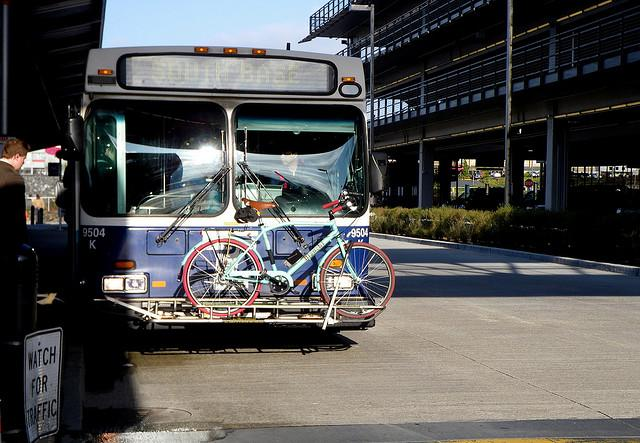Where is the rider of the bike? Please explain your reasoning. in bus. The bike is stored on the front of the bus because it belongs to one of the passengers. there is not room inside the bus for the bike and the rack provides convenient storage. 